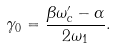<formula> <loc_0><loc_0><loc_500><loc_500>\gamma _ { 0 } = \frac { \beta \omega _ { c } ^ { \prime } - \alpha } { 2 \omega _ { 1 } } .</formula> 